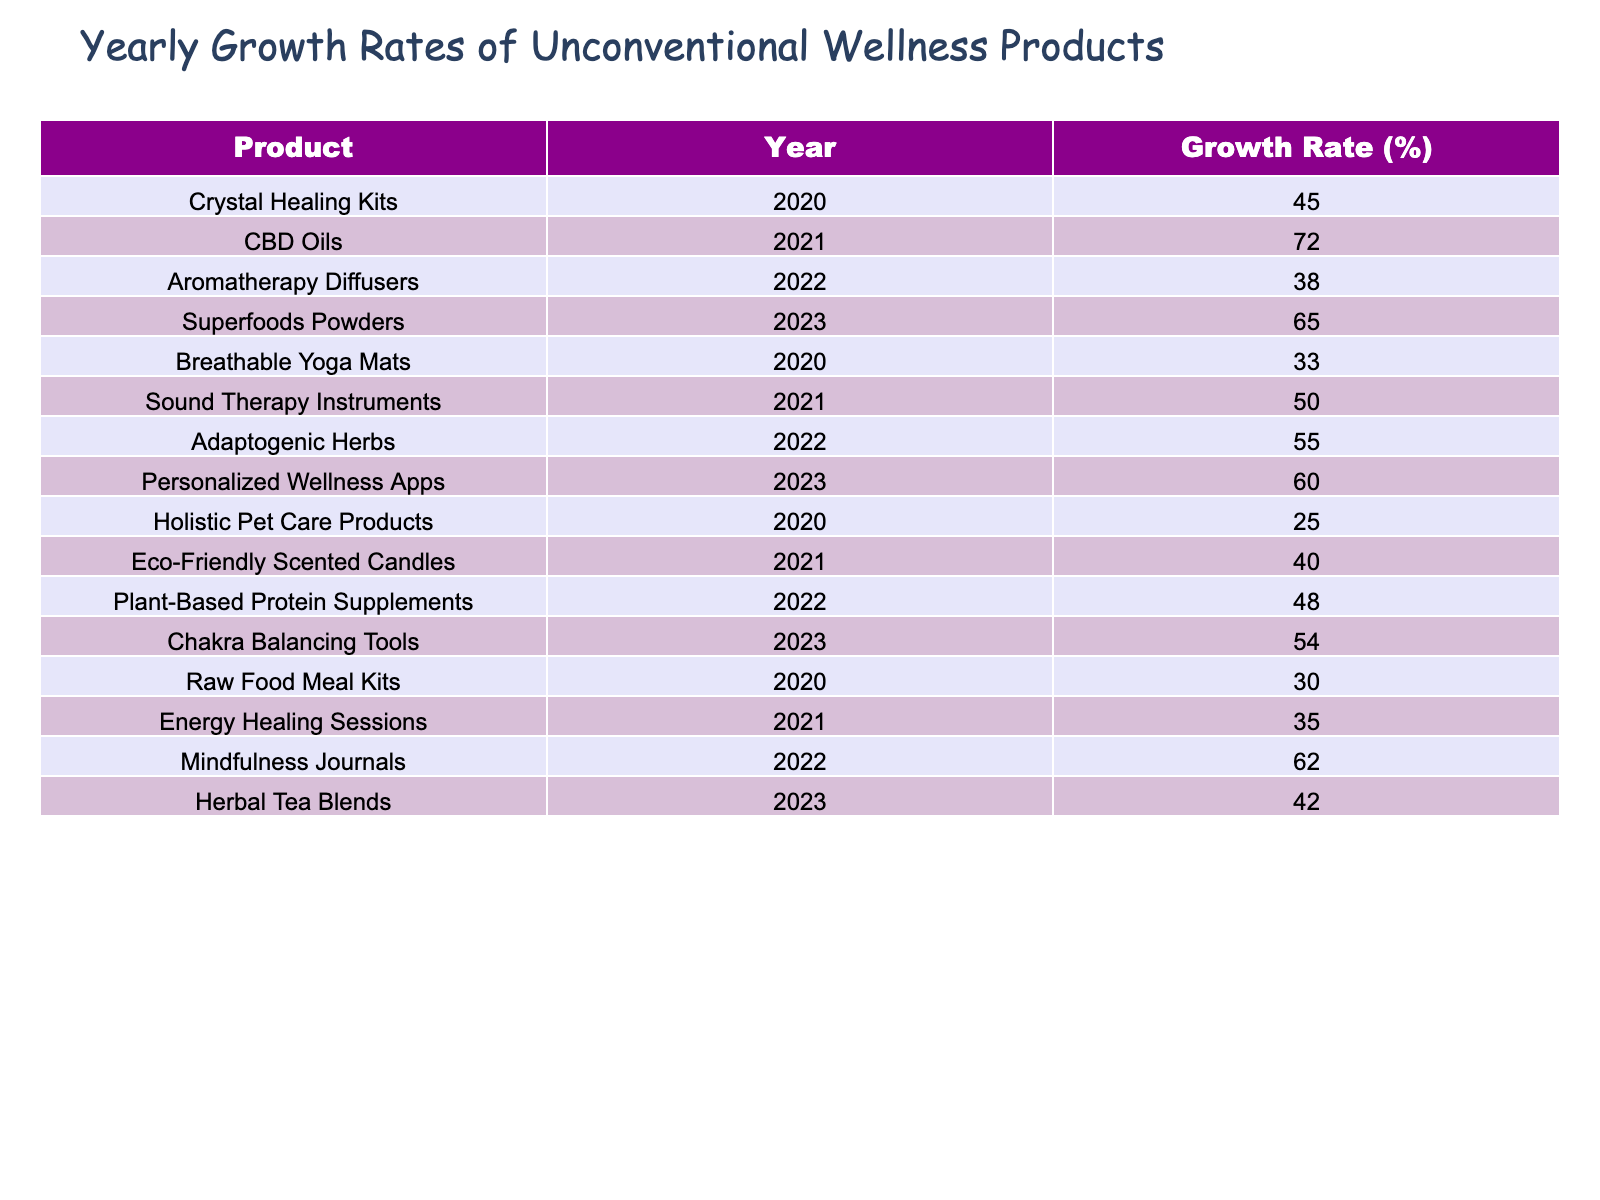What was the highest growth rate recorded in 2021? Referring to the table, the highest growth rate in 2021 is that of CBD Oils, which shows a growth rate of 72%.
Answer: 72% Which product saw a growth rate of 38% in 2022? Looking at the table, Aromatherapy Diffusers recorded a growth rate of 38% in 2022.
Answer: Aromatherapy Diffusers What is the average growth rate for the year 2020? The growth rates for 2020 are 45%, 33%, 25%, and 30%. The average is calculated as (45 + 33 + 25 + 30) / 4 = 33.25%.
Answer: 33.25% Was there any product with a growth rate below 30% in 2023? Checking the 2023 growth rates, the lowest is 42% for Herbal Tea Blends, which means there was no product below 30%.
Answer: No What is the difference between the growth rates of Energy Healing Sessions in 2021 and Breathable Yoga Mats in 2020? Energy Healing Sessions in 2021 had a growth rate of 35%, while Breathable Yoga Mats in 2020 had a growth rate of 33%. The difference is 35 - 33 = 2.
Answer: 2 Which product had the highest growth rate in 2022, and what was it? The highest growth rate in 2022 is for Mindfulness Journals, which had a growth rate of 62%.
Answer: Mindfulness Journals, 62% What is the total growth rate of the products listed for the year 2023? The growth rates for 2023 are 65%, 60%, 54%, and 42%. Adding these gives 65 + 60 + 54 + 42 = 221%.
Answer: 221% How many products recorded a growth rate of 50% or more in 2021? In 2021, the products are CBD Oils (72%) and Sound Therapy Instruments (50%). There are 2 products that meet this criterion.
Answer: 2 Which product showed a 25% growth rate, and in which year? The table shows that Holistic Pet Care Products had a 25% growth rate in 2020.
Answer: Holistic Pet Care Products, 2020 If we compare the growth rate of Superfoods Powders in 2023 to Herbal Tea Blends in 2023, what is the conclusion? Superfoods Powders had a growth rate of 65%, while Herbal Tea Blends had 42%. Therefore, Superfoods Powders grew significantly more than Herbal Tea Blends in 2023.
Answer: Superfoods Powders grew more 